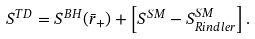<formula> <loc_0><loc_0><loc_500><loc_500>S ^ { T D } = S ^ { B H } ( \bar { r } _ { + } ) + \left [ S ^ { S M } - S ^ { S M } _ { R i n d l e r } \right ] .</formula> 